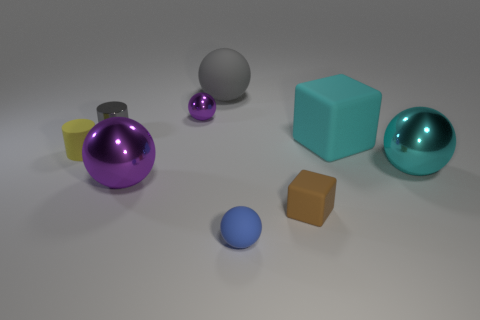Subtract all gray spheres. How many spheres are left? 4 Subtract all large purple balls. How many balls are left? 4 Subtract 2 spheres. How many spheres are left? 3 Subtract all green balls. Subtract all green cylinders. How many balls are left? 5 Add 1 gray balls. How many objects exist? 10 Subtract all cubes. How many objects are left? 7 Subtract all large matte things. Subtract all small metal objects. How many objects are left? 5 Add 5 brown rubber objects. How many brown rubber objects are left? 6 Add 3 large cyan balls. How many large cyan balls exist? 4 Subtract 1 yellow cylinders. How many objects are left? 8 